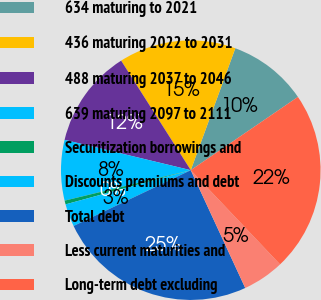Convert chart. <chart><loc_0><loc_0><loc_500><loc_500><pie_chart><fcel>634 maturing to 2021<fcel>436 maturing 2022 to 2031<fcel>488 maturing 2037 to 2046<fcel>639 maturing 2097 to 2111<fcel>Securitization borrowings and<fcel>Discounts premiums and debt<fcel>Total debt<fcel>Less current maturities and<fcel>Long-term debt excluding<nl><fcel>9.88%<fcel>14.59%<fcel>12.23%<fcel>7.53%<fcel>0.47%<fcel>2.83%<fcel>24.82%<fcel>5.18%<fcel>22.47%<nl></chart> 